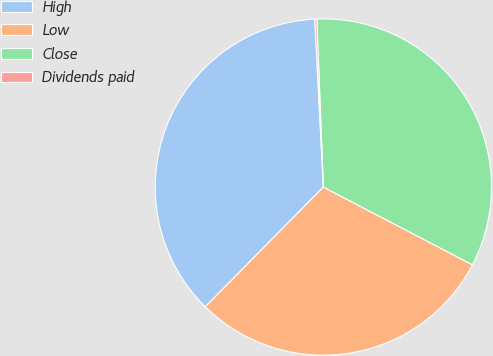Convert chart. <chart><loc_0><loc_0><loc_500><loc_500><pie_chart><fcel>High<fcel>Low<fcel>Close<fcel>Dividends paid<nl><fcel>36.81%<fcel>29.73%<fcel>33.27%<fcel>0.19%<nl></chart> 